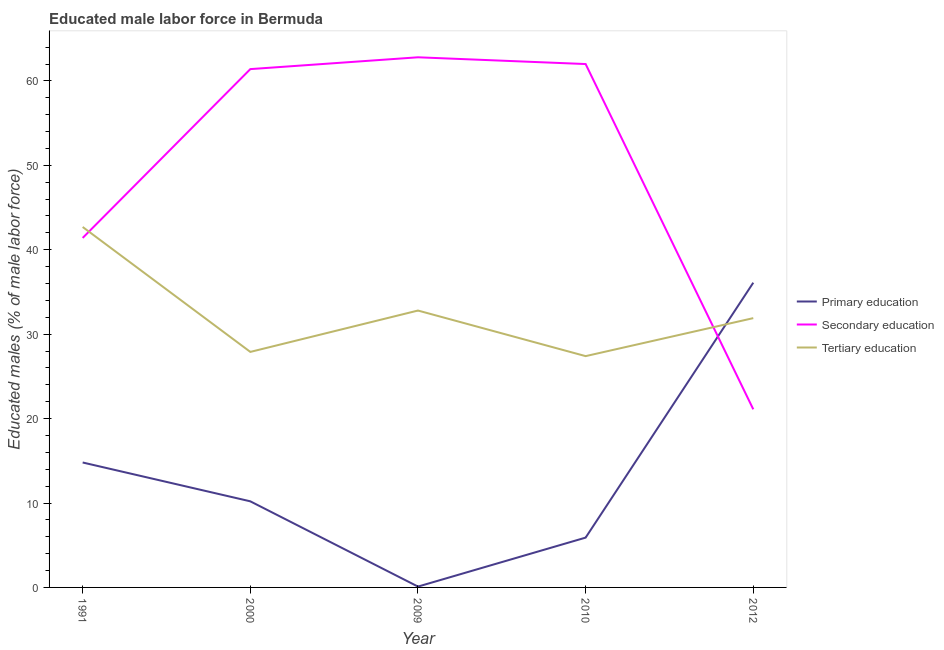Does the line corresponding to percentage of male labor force who received tertiary education intersect with the line corresponding to percentage of male labor force who received secondary education?
Ensure brevity in your answer.  Yes. What is the percentage of male labor force who received tertiary education in 2000?
Give a very brief answer. 27.9. Across all years, what is the maximum percentage of male labor force who received tertiary education?
Ensure brevity in your answer.  42.7. Across all years, what is the minimum percentage of male labor force who received secondary education?
Provide a succinct answer. 21.1. In which year was the percentage of male labor force who received primary education maximum?
Provide a short and direct response. 2012. What is the total percentage of male labor force who received primary education in the graph?
Offer a terse response. 67.1. What is the difference between the percentage of male labor force who received tertiary education in 1991 and that in 2000?
Your answer should be very brief. 14.8. What is the difference between the percentage of male labor force who received secondary education in 2010 and the percentage of male labor force who received primary education in 2009?
Offer a terse response. 61.9. What is the average percentage of male labor force who received primary education per year?
Provide a short and direct response. 13.42. In the year 2012, what is the difference between the percentage of male labor force who received secondary education and percentage of male labor force who received tertiary education?
Your answer should be compact. -10.8. In how many years, is the percentage of male labor force who received primary education greater than 38 %?
Make the answer very short. 0. What is the ratio of the percentage of male labor force who received primary education in 1991 to that in 2009?
Give a very brief answer. 148. Is the percentage of male labor force who received primary education in 2000 less than that in 2012?
Offer a terse response. Yes. What is the difference between the highest and the second highest percentage of male labor force who received primary education?
Your response must be concise. 21.3. What is the difference between the highest and the lowest percentage of male labor force who received secondary education?
Your answer should be very brief. 41.7. Does the percentage of male labor force who received tertiary education monotonically increase over the years?
Keep it short and to the point. No. Is the percentage of male labor force who received tertiary education strictly greater than the percentage of male labor force who received secondary education over the years?
Keep it short and to the point. No. Is the percentage of male labor force who received primary education strictly less than the percentage of male labor force who received secondary education over the years?
Give a very brief answer. No. What is the difference between two consecutive major ticks on the Y-axis?
Offer a very short reply. 10. Does the graph contain grids?
Your response must be concise. No. Where does the legend appear in the graph?
Keep it short and to the point. Center right. How many legend labels are there?
Provide a short and direct response. 3. What is the title of the graph?
Offer a very short reply. Educated male labor force in Bermuda. Does "Taxes on income" appear as one of the legend labels in the graph?
Offer a terse response. No. What is the label or title of the X-axis?
Make the answer very short. Year. What is the label or title of the Y-axis?
Give a very brief answer. Educated males (% of male labor force). What is the Educated males (% of male labor force) of Primary education in 1991?
Ensure brevity in your answer.  14.8. What is the Educated males (% of male labor force) in Secondary education in 1991?
Your response must be concise. 41.4. What is the Educated males (% of male labor force) in Tertiary education in 1991?
Your response must be concise. 42.7. What is the Educated males (% of male labor force) in Primary education in 2000?
Provide a short and direct response. 10.2. What is the Educated males (% of male labor force) in Secondary education in 2000?
Give a very brief answer. 61.4. What is the Educated males (% of male labor force) of Tertiary education in 2000?
Offer a very short reply. 27.9. What is the Educated males (% of male labor force) in Primary education in 2009?
Make the answer very short. 0.1. What is the Educated males (% of male labor force) of Secondary education in 2009?
Provide a succinct answer. 62.8. What is the Educated males (% of male labor force) of Tertiary education in 2009?
Keep it short and to the point. 32.8. What is the Educated males (% of male labor force) in Primary education in 2010?
Keep it short and to the point. 5.9. What is the Educated males (% of male labor force) of Secondary education in 2010?
Give a very brief answer. 62. What is the Educated males (% of male labor force) of Tertiary education in 2010?
Keep it short and to the point. 27.4. What is the Educated males (% of male labor force) of Primary education in 2012?
Offer a terse response. 36.1. What is the Educated males (% of male labor force) of Secondary education in 2012?
Keep it short and to the point. 21.1. What is the Educated males (% of male labor force) in Tertiary education in 2012?
Offer a terse response. 31.9. Across all years, what is the maximum Educated males (% of male labor force) in Primary education?
Your response must be concise. 36.1. Across all years, what is the maximum Educated males (% of male labor force) of Secondary education?
Make the answer very short. 62.8. Across all years, what is the maximum Educated males (% of male labor force) of Tertiary education?
Ensure brevity in your answer.  42.7. Across all years, what is the minimum Educated males (% of male labor force) of Primary education?
Offer a very short reply. 0.1. Across all years, what is the minimum Educated males (% of male labor force) in Secondary education?
Your answer should be very brief. 21.1. Across all years, what is the minimum Educated males (% of male labor force) of Tertiary education?
Offer a very short reply. 27.4. What is the total Educated males (% of male labor force) of Primary education in the graph?
Provide a succinct answer. 67.1. What is the total Educated males (% of male labor force) in Secondary education in the graph?
Offer a terse response. 248.7. What is the total Educated males (% of male labor force) in Tertiary education in the graph?
Your answer should be very brief. 162.7. What is the difference between the Educated males (% of male labor force) in Secondary education in 1991 and that in 2000?
Give a very brief answer. -20. What is the difference between the Educated males (% of male labor force) of Secondary education in 1991 and that in 2009?
Make the answer very short. -21.4. What is the difference between the Educated males (% of male labor force) in Tertiary education in 1991 and that in 2009?
Your response must be concise. 9.9. What is the difference between the Educated males (% of male labor force) in Primary education in 1991 and that in 2010?
Ensure brevity in your answer.  8.9. What is the difference between the Educated males (% of male labor force) of Secondary education in 1991 and that in 2010?
Ensure brevity in your answer.  -20.6. What is the difference between the Educated males (% of male labor force) in Primary education in 1991 and that in 2012?
Keep it short and to the point. -21.3. What is the difference between the Educated males (% of male labor force) of Secondary education in 1991 and that in 2012?
Keep it short and to the point. 20.3. What is the difference between the Educated males (% of male labor force) of Secondary education in 2000 and that in 2009?
Offer a very short reply. -1.4. What is the difference between the Educated males (% of male labor force) in Tertiary education in 2000 and that in 2009?
Make the answer very short. -4.9. What is the difference between the Educated males (% of male labor force) in Secondary education in 2000 and that in 2010?
Provide a succinct answer. -0.6. What is the difference between the Educated males (% of male labor force) in Primary education in 2000 and that in 2012?
Your answer should be very brief. -25.9. What is the difference between the Educated males (% of male labor force) in Secondary education in 2000 and that in 2012?
Give a very brief answer. 40.3. What is the difference between the Educated males (% of male labor force) of Primary education in 2009 and that in 2010?
Your answer should be compact. -5.8. What is the difference between the Educated males (% of male labor force) of Secondary education in 2009 and that in 2010?
Make the answer very short. 0.8. What is the difference between the Educated males (% of male labor force) in Tertiary education in 2009 and that in 2010?
Provide a short and direct response. 5.4. What is the difference between the Educated males (% of male labor force) in Primary education in 2009 and that in 2012?
Make the answer very short. -36. What is the difference between the Educated males (% of male labor force) in Secondary education in 2009 and that in 2012?
Give a very brief answer. 41.7. What is the difference between the Educated males (% of male labor force) in Tertiary education in 2009 and that in 2012?
Your response must be concise. 0.9. What is the difference between the Educated males (% of male labor force) in Primary education in 2010 and that in 2012?
Make the answer very short. -30.2. What is the difference between the Educated males (% of male labor force) of Secondary education in 2010 and that in 2012?
Ensure brevity in your answer.  40.9. What is the difference between the Educated males (% of male labor force) in Tertiary education in 2010 and that in 2012?
Keep it short and to the point. -4.5. What is the difference between the Educated males (% of male labor force) in Primary education in 1991 and the Educated males (% of male labor force) in Secondary education in 2000?
Make the answer very short. -46.6. What is the difference between the Educated males (% of male labor force) of Secondary education in 1991 and the Educated males (% of male labor force) of Tertiary education in 2000?
Keep it short and to the point. 13.5. What is the difference between the Educated males (% of male labor force) in Primary education in 1991 and the Educated males (% of male labor force) in Secondary education in 2009?
Ensure brevity in your answer.  -48. What is the difference between the Educated males (% of male labor force) in Primary education in 1991 and the Educated males (% of male labor force) in Secondary education in 2010?
Give a very brief answer. -47.2. What is the difference between the Educated males (% of male labor force) of Primary education in 1991 and the Educated males (% of male labor force) of Secondary education in 2012?
Offer a terse response. -6.3. What is the difference between the Educated males (% of male labor force) in Primary education in 1991 and the Educated males (% of male labor force) in Tertiary education in 2012?
Offer a very short reply. -17.1. What is the difference between the Educated males (% of male labor force) of Secondary education in 1991 and the Educated males (% of male labor force) of Tertiary education in 2012?
Offer a terse response. 9.5. What is the difference between the Educated males (% of male labor force) in Primary education in 2000 and the Educated males (% of male labor force) in Secondary education in 2009?
Ensure brevity in your answer.  -52.6. What is the difference between the Educated males (% of male labor force) in Primary education in 2000 and the Educated males (% of male labor force) in Tertiary education in 2009?
Offer a very short reply. -22.6. What is the difference between the Educated males (% of male labor force) of Secondary education in 2000 and the Educated males (% of male labor force) of Tertiary education in 2009?
Your answer should be compact. 28.6. What is the difference between the Educated males (% of male labor force) of Primary education in 2000 and the Educated males (% of male labor force) of Secondary education in 2010?
Offer a terse response. -51.8. What is the difference between the Educated males (% of male labor force) of Primary education in 2000 and the Educated males (% of male labor force) of Tertiary education in 2010?
Offer a very short reply. -17.2. What is the difference between the Educated males (% of male labor force) of Secondary education in 2000 and the Educated males (% of male labor force) of Tertiary education in 2010?
Ensure brevity in your answer.  34. What is the difference between the Educated males (% of male labor force) in Primary education in 2000 and the Educated males (% of male labor force) in Tertiary education in 2012?
Your answer should be very brief. -21.7. What is the difference between the Educated males (% of male labor force) of Secondary education in 2000 and the Educated males (% of male labor force) of Tertiary education in 2012?
Your response must be concise. 29.5. What is the difference between the Educated males (% of male labor force) in Primary education in 2009 and the Educated males (% of male labor force) in Secondary education in 2010?
Make the answer very short. -61.9. What is the difference between the Educated males (% of male labor force) in Primary education in 2009 and the Educated males (% of male labor force) in Tertiary education in 2010?
Offer a terse response. -27.3. What is the difference between the Educated males (% of male labor force) in Secondary education in 2009 and the Educated males (% of male labor force) in Tertiary education in 2010?
Your answer should be compact. 35.4. What is the difference between the Educated males (% of male labor force) in Primary education in 2009 and the Educated males (% of male labor force) in Tertiary education in 2012?
Make the answer very short. -31.8. What is the difference between the Educated males (% of male labor force) of Secondary education in 2009 and the Educated males (% of male labor force) of Tertiary education in 2012?
Ensure brevity in your answer.  30.9. What is the difference between the Educated males (% of male labor force) of Primary education in 2010 and the Educated males (% of male labor force) of Secondary education in 2012?
Provide a succinct answer. -15.2. What is the difference between the Educated males (% of male labor force) of Secondary education in 2010 and the Educated males (% of male labor force) of Tertiary education in 2012?
Your answer should be very brief. 30.1. What is the average Educated males (% of male labor force) in Primary education per year?
Your answer should be very brief. 13.42. What is the average Educated males (% of male labor force) in Secondary education per year?
Give a very brief answer. 49.74. What is the average Educated males (% of male labor force) of Tertiary education per year?
Ensure brevity in your answer.  32.54. In the year 1991, what is the difference between the Educated males (% of male labor force) of Primary education and Educated males (% of male labor force) of Secondary education?
Give a very brief answer. -26.6. In the year 1991, what is the difference between the Educated males (% of male labor force) in Primary education and Educated males (% of male labor force) in Tertiary education?
Provide a succinct answer. -27.9. In the year 2000, what is the difference between the Educated males (% of male labor force) in Primary education and Educated males (% of male labor force) in Secondary education?
Offer a terse response. -51.2. In the year 2000, what is the difference between the Educated males (% of male labor force) of Primary education and Educated males (% of male labor force) of Tertiary education?
Provide a succinct answer. -17.7. In the year 2000, what is the difference between the Educated males (% of male labor force) of Secondary education and Educated males (% of male labor force) of Tertiary education?
Offer a very short reply. 33.5. In the year 2009, what is the difference between the Educated males (% of male labor force) in Primary education and Educated males (% of male labor force) in Secondary education?
Give a very brief answer. -62.7. In the year 2009, what is the difference between the Educated males (% of male labor force) of Primary education and Educated males (% of male labor force) of Tertiary education?
Make the answer very short. -32.7. In the year 2010, what is the difference between the Educated males (% of male labor force) of Primary education and Educated males (% of male labor force) of Secondary education?
Your response must be concise. -56.1. In the year 2010, what is the difference between the Educated males (% of male labor force) of Primary education and Educated males (% of male labor force) of Tertiary education?
Keep it short and to the point. -21.5. In the year 2010, what is the difference between the Educated males (% of male labor force) in Secondary education and Educated males (% of male labor force) in Tertiary education?
Offer a very short reply. 34.6. What is the ratio of the Educated males (% of male labor force) in Primary education in 1991 to that in 2000?
Give a very brief answer. 1.45. What is the ratio of the Educated males (% of male labor force) of Secondary education in 1991 to that in 2000?
Your answer should be compact. 0.67. What is the ratio of the Educated males (% of male labor force) in Tertiary education in 1991 to that in 2000?
Keep it short and to the point. 1.53. What is the ratio of the Educated males (% of male labor force) in Primary education in 1991 to that in 2009?
Your answer should be very brief. 148. What is the ratio of the Educated males (% of male labor force) of Secondary education in 1991 to that in 2009?
Provide a short and direct response. 0.66. What is the ratio of the Educated males (% of male labor force) of Tertiary education in 1991 to that in 2009?
Provide a short and direct response. 1.3. What is the ratio of the Educated males (% of male labor force) in Primary education in 1991 to that in 2010?
Provide a succinct answer. 2.51. What is the ratio of the Educated males (% of male labor force) of Secondary education in 1991 to that in 2010?
Provide a short and direct response. 0.67. What is the ratio of the Educated males (% of male labor force) of Tertiary education in 1991 to that in 2010?
Give a very brief answer. 1.56. What is the ratio of the Educated males (% of male labor force) of Primary education in 1991 to that in 2012?
Your response must be concise. 0.41. What is the ratio of the Educated males (% of male labor force) of Secondary education in 1991 to that in 2012?
Provide a succinct answer. 1.96. What is the ratio of the Educated males (% of male labor force) in Tertiary education in 1991 to that in 2012?
Keep it short and to the point. 1.34. What is the ratio of the Educated males (% of male labor force) in Primary education in 2000 to that in 2009?
Give a very brief answer. 102. What is the ratio of the Educated males (% of male labor force) in Secondary education in 2000 to that in 2009?
Give a very brief answer. 0.98. What is the ratio of the Educated males (% of male labor force) in Tertiary education in 2000 to that in 2009?
Ensure brevity in your answer.  0.85. What is the ratio of the Educated males (% of male labor force) in Primary education in 2000 to that in 2010?
Your answer should be very brief. 1.73. What is the ratio of the Educated males (% of male labor force) of Secondary education in 2000 to that in 2010?
Keep it short and to the point. 0.99. What is the ratio of the Educated males (% of male labor force) in Tertiary education in 2000 to that in 2010?
Your answer should be very brief. 1.02. What is the ratio of the Educated males (% of male labor force) of Primary education in 2000 to that in 2012?
Provide a succinct answer. 0.28. What is the ratio of the Educated males (% of male labor force) in Secondary education in 2000 to that in 2012?
Keep it short and to the point. 2.91. What is the ratio of the Educated males (% of male labor force) of Tertiary education in 2000 to that in 2012?
Ensure brevity in your answer.  0.87. What is the ratio of the Educated males (% of male labor force) of Primary education in 2009 to that in 2010?
Offer a terse response. 0.02. What is the ratio of the Educated males (% of male labor force) of Secondary education in 2009 to that in 2010?
Provide a succinct answer. 1.01. What is the ratio of the Educated males (% of male labor force) in Tertiary education in 2009 to that in 2010?
Provide a short and direct response. 1.2. What is the ratio of the Educated males (% of male labor force) of Primary education in 2009 to that in 2012?
Provide a short and direct response. 0. What is the ratio of the Educated males (% of male labor force) of Secondary education in 2009 to that in 2012?
Ensure brevity in your answer.  2.98. What is the ratio of the Educated males (% of male labor force) of Tertiary education in 2009 to that in 2012?
Your answer should be compact. 1.03. What is the ratio of the Educated males (% of male labor force) of Primary education in 2010 to that in 2012?
Your answer should be compact. 0.16. What is the ratio of the Educated males (% of male labor force) in Secondary education in 2010 to that in 2012?
Your answer should be compact. 2.94. What is the ratio of the Educated males (% of male labor force) in Tertiary education in 2010 to that in 2012?
Provide a short and direct response. 0.86. What is the difference between the highest and the second highest Educated males (% of male labor force) of Primary education?
Ensure brevity in your answer.  21.3. What is the difference between the highest and the second highest Educated males (% of male labor force) of Tertiary education?
Your answer should be compact. 9.9. What is the difference between the highest and the lowest Educated males (% of male labor force) of Primary education?
Your answer should be compact. 36. What is the difference between the highest and the lowest Educated males (% of male labor force) in Secondary education?
Provide a succinct answer. 41.7. What is the difference between the highest and the lowest Educated males (% of male labor force) in Tertiary education?
Provide a succinct answer. 15.3. 